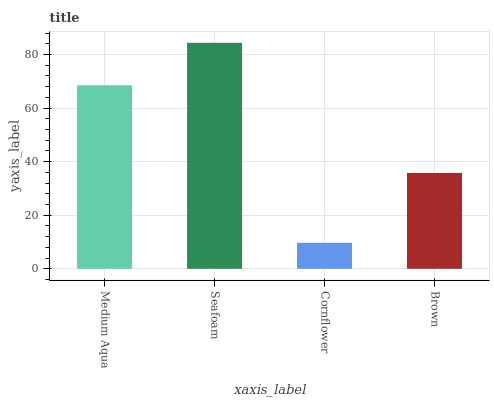Is Seafoam the minimum?
Answer yes or no. No. Is Cornflower the maximum?
Answer yes or no. No. Is Seafoam greater than Cornflower?
Answer yes or no. Yes. Is Cornflower less than Seafoam?
Answer yes or no. Yes. Is Cornflower greater than Seafoam?
Answer yes or no. No. Is Seafoam less than Cornflower?
Answer yes or no. No. Is Medium Aqua the high median?
Answer yes or no. Yes. Is Brown the low median?
Answer yes or no. Yes. Is Cornflower the high median?
Answer yes or no. No. Is Seafoam the low median?
Answer yes or no. No. 